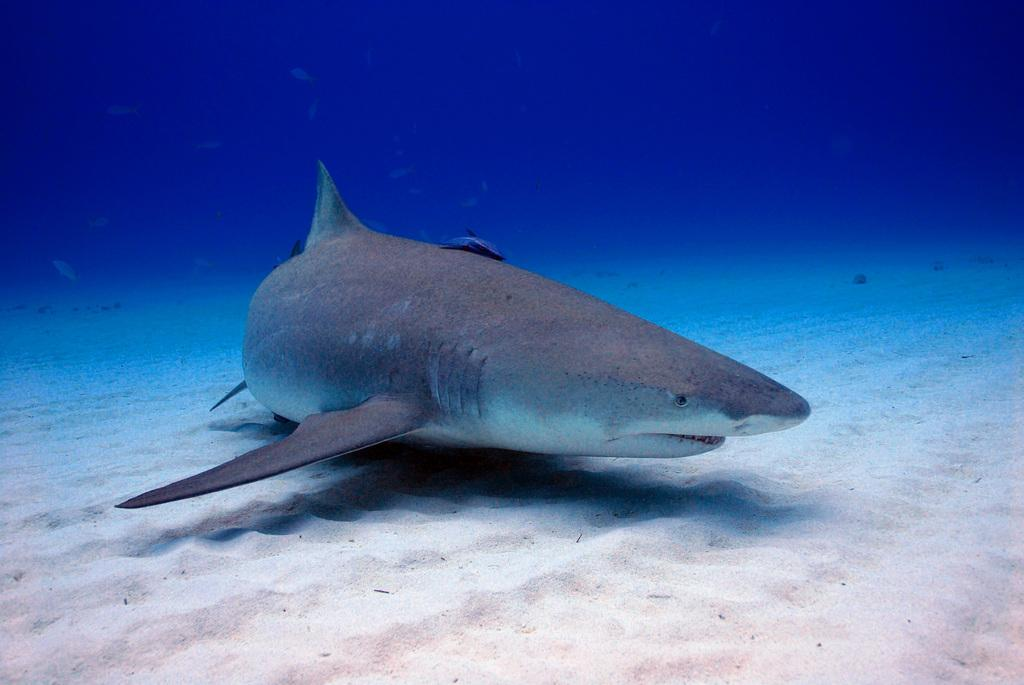What animal is in the image? There is a dolphin in the image. Where is the dolphin located? The dolphin is in the water. What effect does the dolphin have on the growth of the street in the image? There is no street present in the image, and therefore no effect on its growth can be observed. 